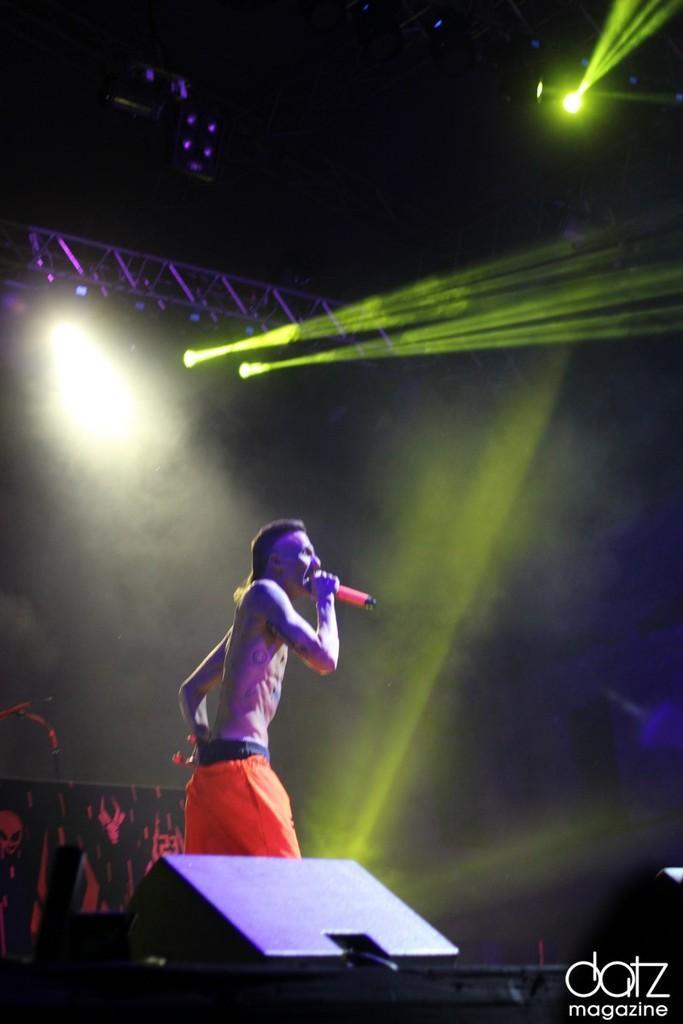Describe this image in one or two sentences. In this image I can see a person standing on the stage, holding a mike in the hand and singing. In the background there are few lights in the dark. At the top of the image there is a metal stand. 